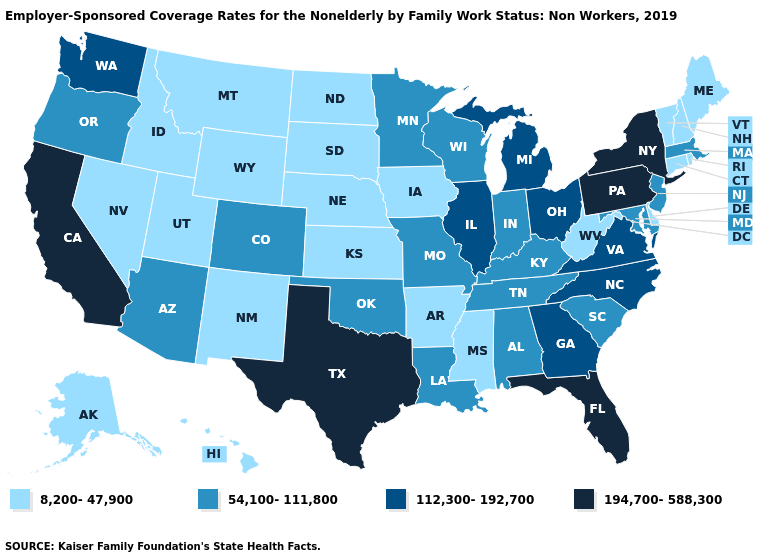Is the legend a continuous bar?
Keep it brief. No. What is the lowest value in the USA?
Answer briefly. 8,200-47,900. What is the lowest value in the USA?
Answer briefly. 8,200-47,900. How many symbols are there in the legend?
Write a very short answer. 4. What is the lowest value in the USA?
Give a very brief answer. 8,200-47,900. Is the legend a continuous bar?
Short answer required. No. Name the states that have a value in the range 112,300-192,700?
Keep it brief. Georgia, Illinois, Michigan, North Carolina, Ohio, Virginia, Washington. Which states have the lowest value in the South?
Short answer required. Arkansas, Delaware, Mississippi, West Virginia. What is the value of Minnesota?
Write a very short answer. 54,100-111,800. Name the states that have a value in the range 54,100-111,800?
Keep it brief. Alabama, Arizona, Colorado, Indiana, Kentucky, Louisiana, Maryland, Massachusetts, Minnesota, Missouri, New Jersey, Oklahoma, Oregon, South Carolina, Tennessee, Wisconsin. What is the value of Connecticut?
Give a very brief answer. 8,200-47,900. Does the map have missing data?
Quick response, please. No. What is the highest value in the USA?
Give a very brief answer. 194,700-588,300. Among the states that border New Jersey , does Delaware have the highest value?
Keep it brief. No. Among the states that border Nevada , does Arizona have the highest value?
Answer briefly. No. 